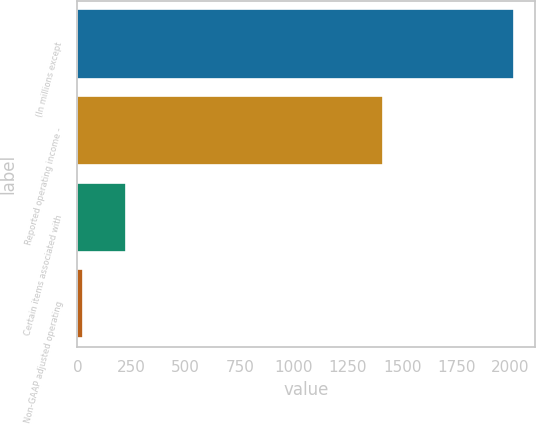<chart> <loc_0><loc_0><loc_500><loc_500><bar_chart><fcel>(In millions except<fcel>Reported operating income -<fcel>Certain items associated with<fcel>Non-GAAP adjusted operating<nl><fcel>2015<fcel>1410<fcel>224.81<fcel>25.9<nl></chart> 